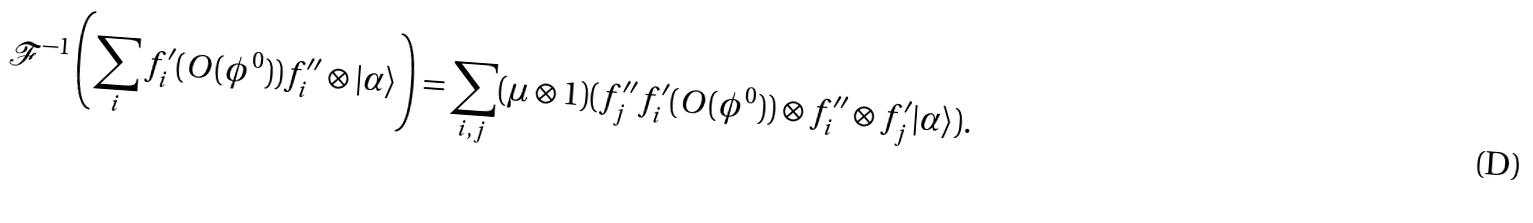<formula> <loc_0><loc_0><loc_500><loc_500>\mathcal { F } ^ { - 1 } \left ( \sum _ { i } f ^ { \prime } _ { i } ( O ( \phi ^ { 0 } ) ) f ^ { \prime \prime } _ { i } \otimes | \alpha \rangle \right ) = \sum _ { i , j } ( \mu \otimes 1 ) ( f ^ { \prime \prime } _ { j } f ^ { \prime } _ { i } ( O ( \phi ^ { 0 } ) ) \otimes f ^ { \prime \prime } _ { i } \otimes f ^ { \prime } _ { j } | \alpha \rangle ) .</formula> 